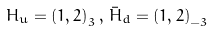<formula> <loc_0><loc_0><loc_500><loc_500>H _ { u } = { ( 1 , 2 ) } _ { 3 } \, , \, \bar { H } _ { d } = { ( 1 , 2 ) } _ { - 3 }</formula> 